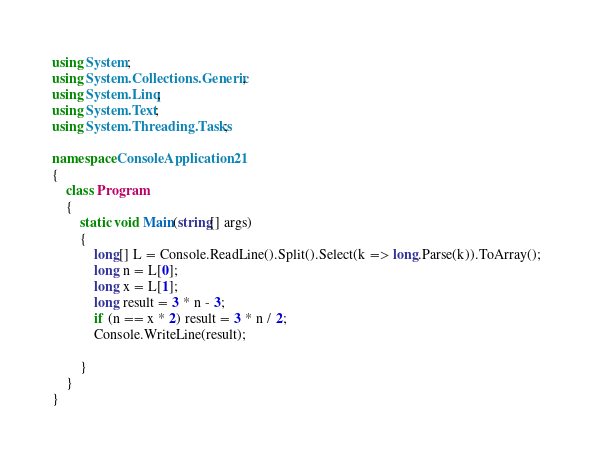<code> <loc_0><loc_0><loc_500><loc_500><_C#_>using System;
using System.Collections.Generic;
using System.Linq;
using System.Text;
using System.Threading.Tasks;

namespace ConsoleApplication21
{
	class Program
	{
		static void Main(string[] args)
		{
			long[] L = Console.ReadLine().Split().Select(k => long.Parse(k)).ToArray();
			long n = L[0];
			long x = L[1];
			long result = 3 * n - 3;
			if (n == x * 2) result = 3 * n / 2;
			Console.WriteLine(result);

		}
	}
}
</code> 